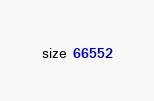<code> <loc_0><loc_0><loc_500><loc_500><_TypeScript_>size 66552
</code> 